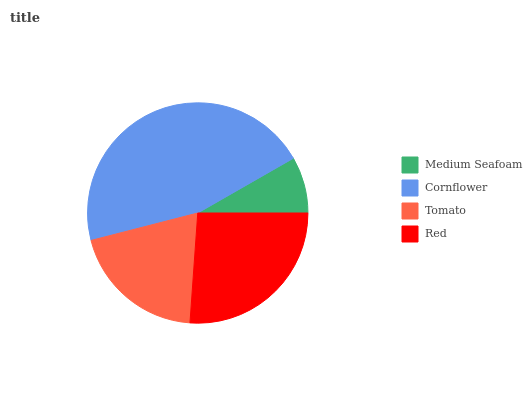Is Medium Seafoam the minimum?
Answer yes or no. Yes. Is Cornflower the maximum?
Answer yes or no. Yes. Is Tomato the minimum?
Answer yes or no. No. Is Tomato the maximum?
Answer yes or no. No. Is Cornflower greater than Tomato?
Answer yes or no. Yes. Is Tomato less than Cornflower?
Answer yes or no. Yes. Is Tomato greater than Cornflower?
Answer yes or no. No. Is Cornflower less than Tomato?
Answer yes or no. No. Is Red the high median?
Answer yes or no. Yes. Is Tomato the low median?
Answer yes or no. Yes. Is Medium Seafoam the high median?
Answer yes or no. No. Is Cornflower the low median?
Answer yes or no. No. 